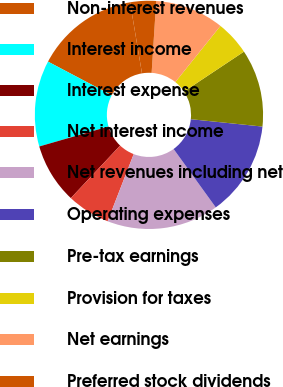<chart> <loc_0><loc_0><loc_500><loc_500><pie_chart><fcel>Non-interest revenues<fcel>Interest income<fcel>Interest expense<fcel>Net interest income<fcel>Net revenues including net<fcel>Operating expenses<fcel>Pre-tax earnings<fcel>Provision for taxes<fcel>Net earnings<fcel>Preferred stock dividends<nl><fcel>14.63%<fcel>12.19%<fcel>8.54%<fcel>6.1%<fcel>15.85%<fcel>13.41%<fcel>10.98%<fcel>4.88%<fcel>9.76%<fcel>3.66%<nl></chart> 